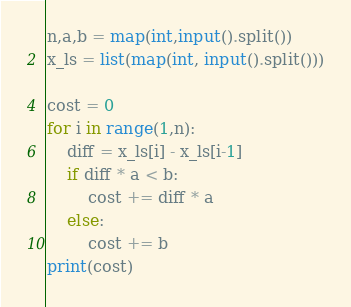<code> <loc_0><loc_0><loc_500><loc_500><_Python_>n,a,b = map(int,input().split())
x_ls = list(map(int, input().split()))

cost = 0
for i in range(1,n):
    diff = x_ls[i] - x_ls[i-1]
    if diff * a < b:
        cost += diff * a
    else:
        cost += b
print(cost)</code> 